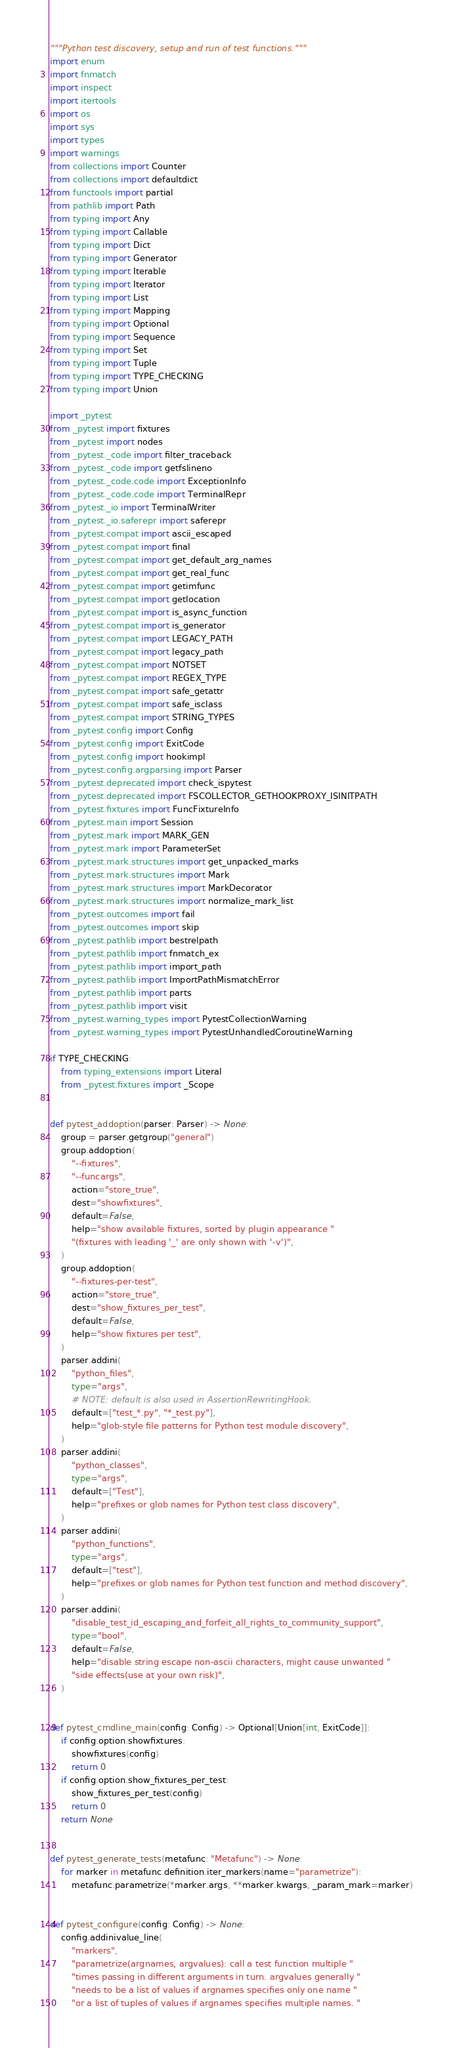Convert code to text. <code><loc_0><loc_0><loc_500><loc_500><_Python_>"""Python test discovery, setup and run of test functions."""
import enum
import fnmatch
import inspect
import itertools
import os
import sys
import types
import warnings
from collections import Counter
from collections import defaultdict
from functools import partial
from pathlib import Path
from typing import Any
from typing import Callable
from typing import Dict
from typing import Generator
from typing import Iterable
from typing import Iterator
from typing import List
from typing import Mapping
from typing import Optional
from typing import Sequence
from typing import Set
from typing import Tuple
from typing import TYPE_CHECKING
from typing import Union

import _pytest
from _pytest import fixtures
from _pytest import nodes
from _pytest._code import filter_traceback
from _pytest._code import getfslineno
from _pytest._code.code import ExceptionInfo
from _pytest._code.code import TerminalRepr
from _pytest._io import TerminalWriter
from _pytest._io.saferepr import saferepr
from _pytest.compat import ascii_escaped
from _pytest.compat import final
from _pytest.compat import get_default_arg_names
from _pytest.compat import get_real_func
from _pytest.compat import getimfunc
from _pytest.compat import getlocation
from _pytest.compat import is_async_function
from _pytest.compat import is_generator
from _pytest.compat import LEGACY_PATH
from _pytest.compat import legacy_path
from _pytest.compat import NOTSET
from _pytest.compat import REGEX_TYPE
from _pytest.compat import safe_getattr
from _pytest.compat import safe_isclass
from _pytest.compat import STRING_TYPES
from _pytest.config import Config
from _pytest.config import ExitCode
from _pytest.config import hookimpl
from _pytest.config.argparsing import Parser
from _pytest.deprecated import check_ispytest
from _pytest.deprecated import FSCOLLECTOR_GETHOOKPROXY_ISINITPATH
from _pytest.fixtures import FuncFixtureInfo
from _pytest.main import Session
from _pytest.mark import MARK_GEN
from _pytest.mark import ParameterSet
from _pytest.mark.structures import get_unpacked_marks
from _pytest.mark.structures import Mark
from _pytest.mark.structures import MarkDecorator
from _pytest.mark.structures import normalize_mark_list
from _pytest.outcomes import fail
from _pytest.outcomes import skip
from _pytest.pathlib import bestrelpath
from _pytest.pathlib import fnmatch_ex
from _pytest.pathlib import import_path
from _pytest.pathlib import ImportPathMismatchError
from _pytest.pathlib import parts
from _pytest.pathlib import visit
from _pytest.warning_types import PytestCollectionWarning
from _pytest.warning_types import PytestUnhandledCoroutineWarning

if TYPE_CHECKING:
    from typing_extensions import Literal
    from _pytest.fixtures import _Scope


def pytest_addoption(parser: Parser) -> None:
    group = parser.getgroup("general")
    group.addoption(
        "--fixtures",
        "--funcargs",
        action="store_true",
        dest="showfixtures",
        default=False,
        help="show available fixtures, sorted by plugin appearance "
        "(fixtures with leading '_' are only shown with '-v')",
    )
    group.addoption(
        "--fixtures-per-test",
        action="store_true",
        dest="show_fixtures_per_test",
        default=False,
        help="show fixtures per test",
    )
    parser.addini(
        "python_files",
        type="args",
        # NOTE: default is also used in AssertionRewritingHook.
        default=["test_*.py", "*_test.py"],
        help="glob-style file patterns for Python test module discovery",
    )
    parser.addini(
        "python_classes",
        type="args",
        default=["Test"],
        help="prefixes or glob names for Python test class discovery",
    )
    parser.addini(
        "python_functions",
        type="args",
        default=["test"],
        help="prefixes or glob names for Python test function and method discovery",
    )
    parser.addini(
        "disable_test_id_escaping_and_forfeit_all_rights_to_community_support",
        type="bool",
        default=False,
        help="disable string escape non-ascii characters, might cause unwanted "
        "side effects(use at your own risk)",
    )


def pytest_cmdline_main(config: Config) -> Optional[Union[int, ExitCode]]:
    if config.option.showfixtures:
        showfixtures(config)
        return 0
    if config.option.show_fixtures_per_test:
        show_fixtures_per_test(config)
        return 0
    return None


def pytest_generate_tests(metafunc: "Metafunc") -> None:
    for marker in metafunc.definition.iter_markers(name="parametrize"):
        metafunc.parametrize(*marker.args, **marker.kwargs, _param_mark=marker)


def pytest_configure(config: Config) -> None:
    config.addinivalue_line(
        "markers",
        "parametrize(argnames, argvalues): call a test function multiple "
        "times passing in different arguments in turn. argvalues generally "
        "needs to be a list of values if argnames specifies only one name "
        "or a list of tuples of values if argnames specifies multiple names. "</code> 